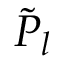<formula> <loc_0><loc_0><loc_500><loc_500>\tilde { P } _ { l }</formula> 